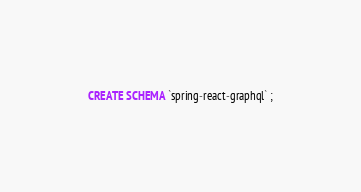<code> <loc_0><loc_0><loc_500><loc_500><_SQL_>CREATE SCHEMA `spring-react-graphql` ;</code> 